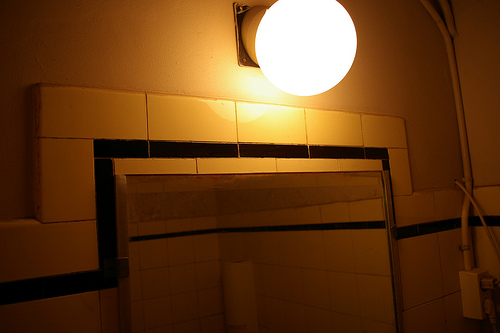<image>
Is the light above the tile? Yes. The light is positioned above the tile in the vertical space, higher up in the scene. Is there a light on the wall? Yes. Looking at the image, I can see the light is positioned on top of the wall, with the wall providing support. 